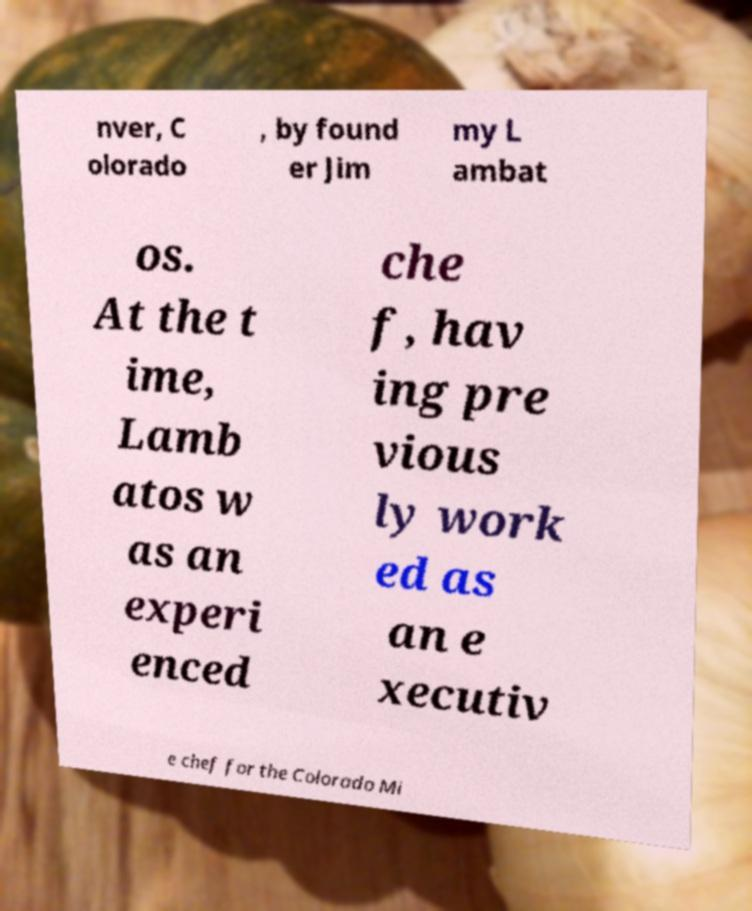Can you read and provide the text displayed in the image?This photo seems to have some interesting text. Can you extract and type it out for me? nver, C olorado , by found er Jim my L ambat os. At the t ime, Lamb atos w as an experi enced che f, hav ing pre vious ly work ed as an e xecutiv e chef for the Colorado Mi 